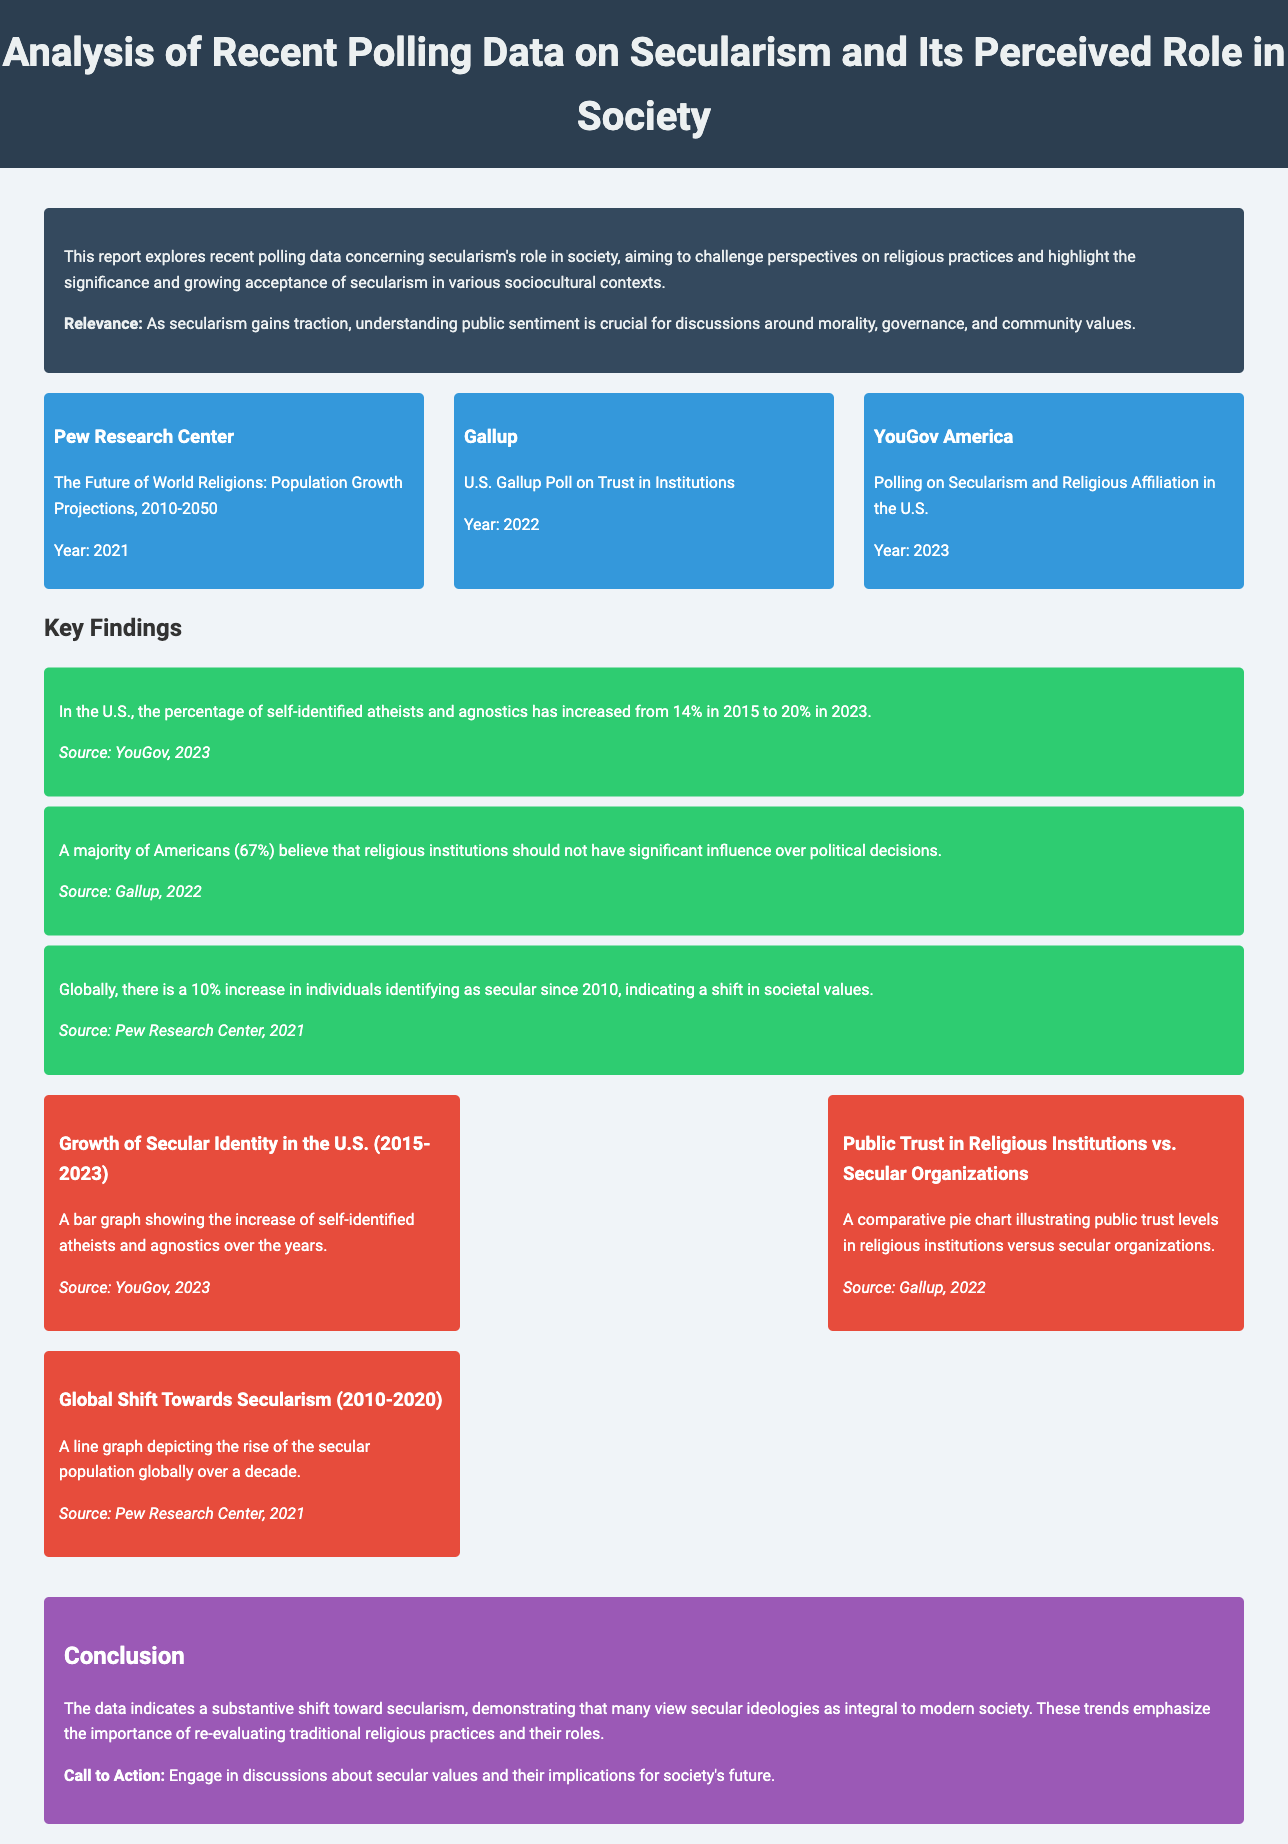What is the title of the report? The title is stated prominently at the top of the document, summarizing its focus on polling data and secularism.
Answer: Analysis of Recent Polling Data on Secularism and Its Perceived Role in Society What percentage of self-identified atheists and agnostics has increased in the U.S. from 2015 to 2023? The report provides specific statistics regarding the growth of secular identity over these years.
Answer: 20% What is the source of the data showing a majority of Americans believe religious institutions should not influence political decisions? Each key finding includes a source that originated from reputable polling organizations, specifically identifying the source for this finding.
Answer: Gallup, 2022 What is the percentage increase of individuals identifying as secular globally since 2010? The report details global trends and shifts in identifying as secular, along with corresponding percentage changes.
Answer: 10% Which organization conducted polling on secularism and religious affiliation in the U.S. in 2023? The source of data for recent secularism polling is mentioned, specifically highlighting the organization responsible for the polling efforts.
Answer: YouGov America What type of graph illustrates the growth of secular identity in the U.S. from 2015 to 2023? The document describes the visual representation of data used to show changes over time in secular identity regarding atheism and agnosticism.
Answer: Bar graph What key conclusion is drawn regarding secularism's role in modern society? The conclusion summarizes the overall findings of the report, emphasizing the significance of secularism in contemporary contexts.
Answer: Substantive shift toward secularism How many sources are listed in the data sources section? The report provides a structured overview of the origins of data, which indicates the total sources referenced within the document.
Answer: 3 